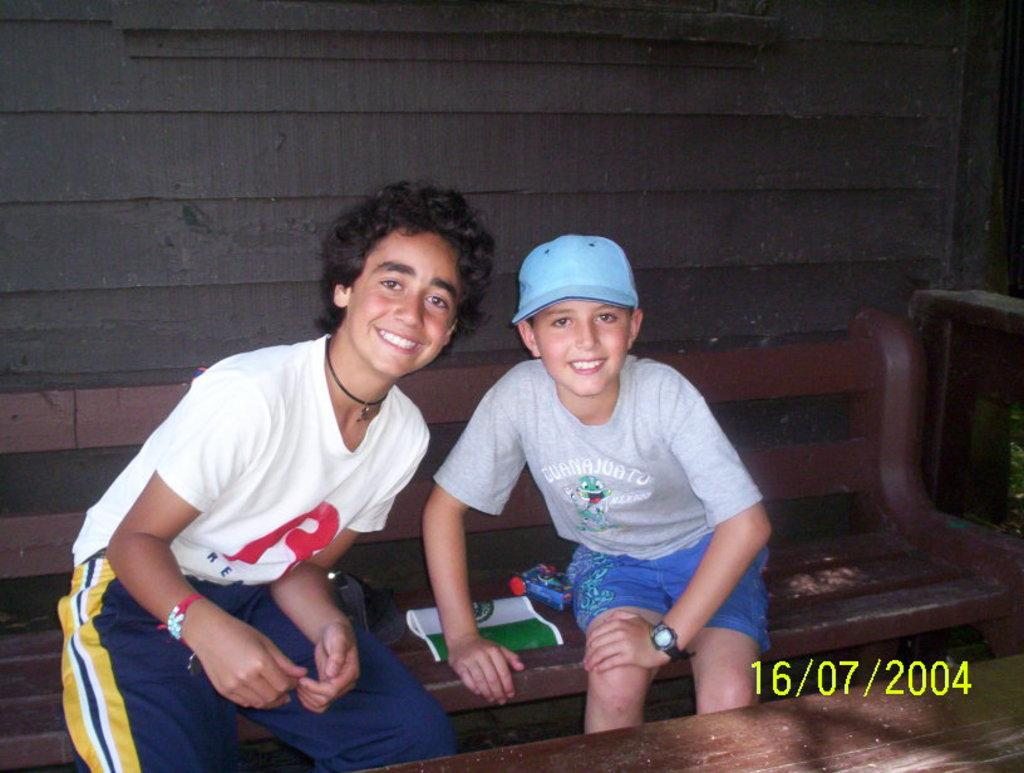How many people are in the image? There are two boys in the image. What are the boys doing in the image? The boys are sitting on a bench and smiling. What might be the reason for their smiles? It appears that the boys are posing for a photo, which could be the reason for their smiles. What type of eggnog is the boys drinking in the image? There is no eggnog present in the image; the boys are sitting on a bench and smiling. What religious beliefs do the boys share in the image? There is no information about the boys' religious beliefs in the image. 